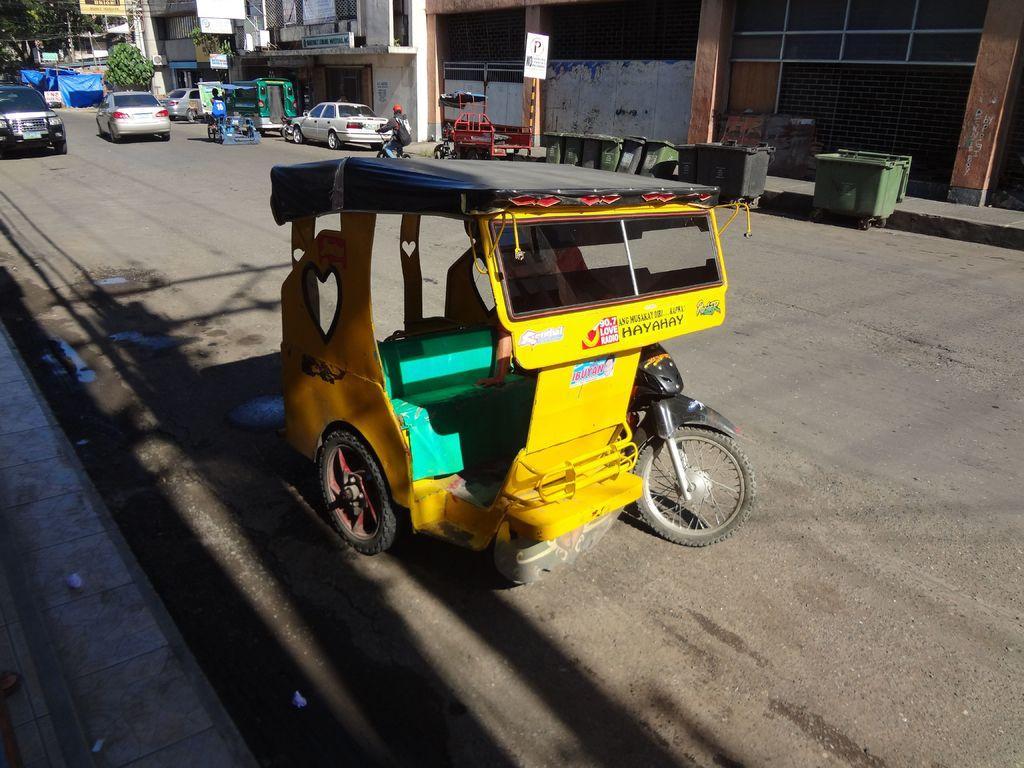Could you give a brief overview of what you see in this image? In this image we can see few vehicles and there are few people riding the vehicles. Behind the vehicles we can see dustbins and buildings. In the top left, we can see the trees, covers and boards with text. 